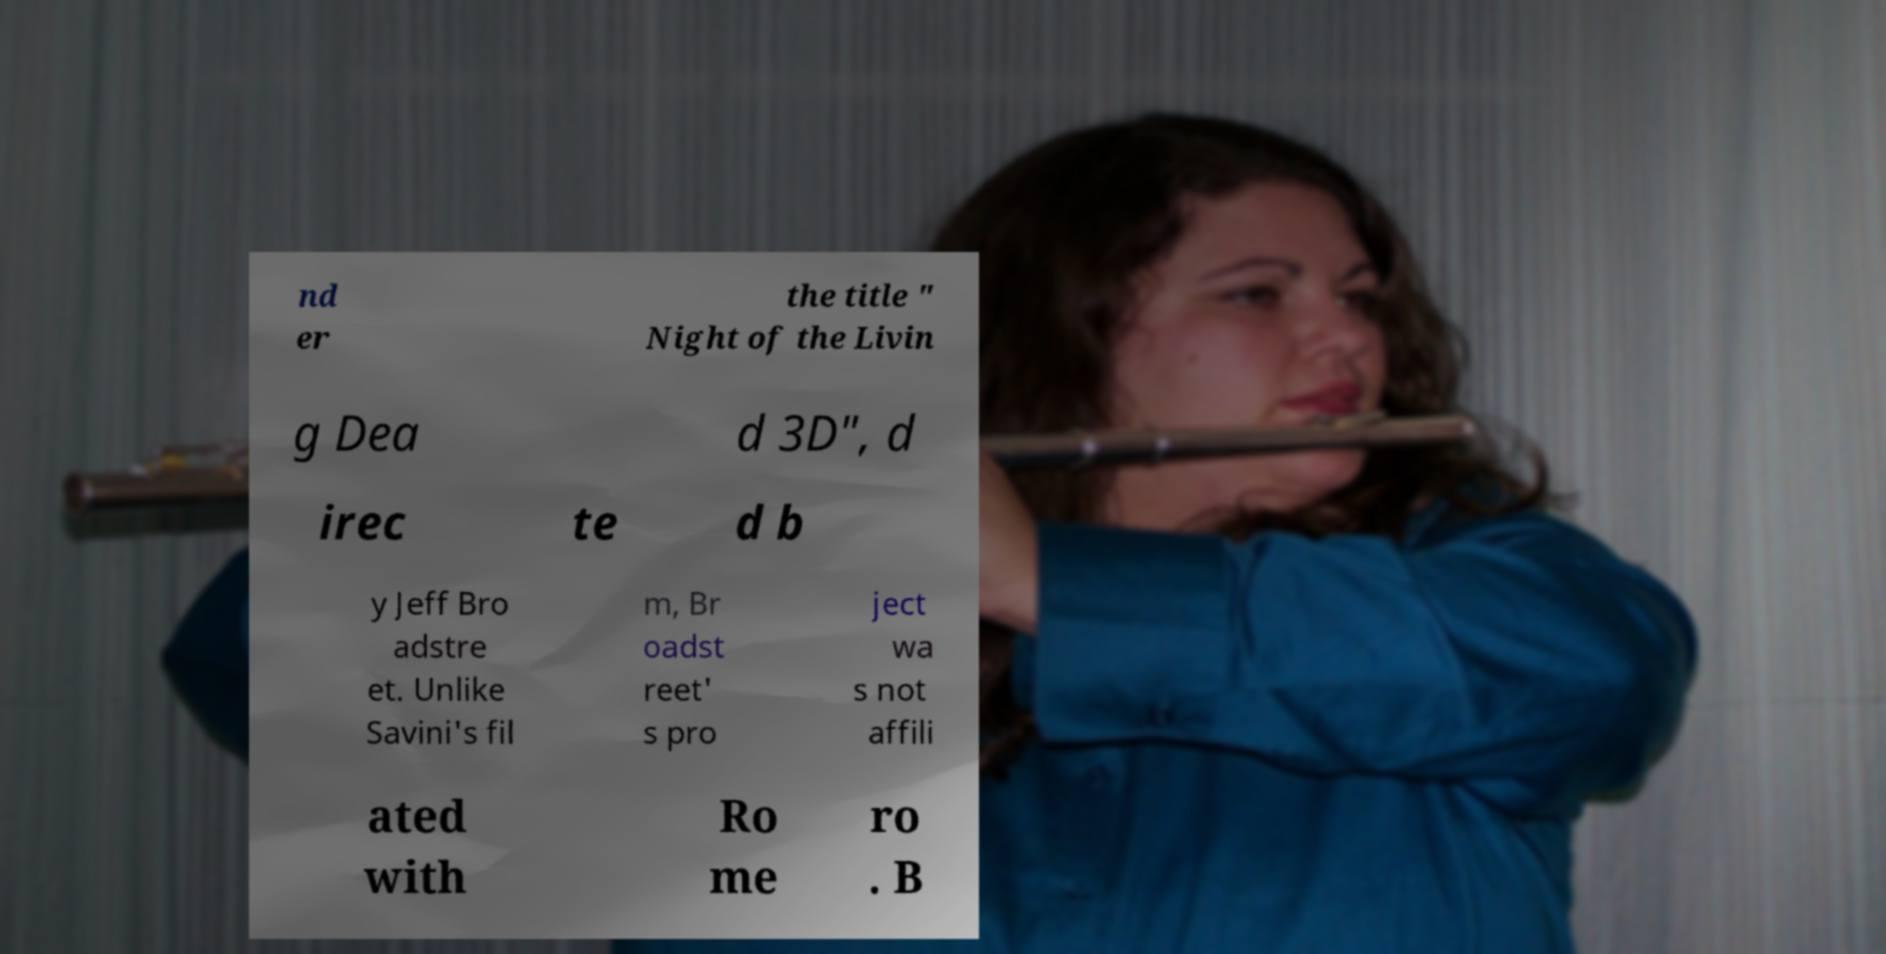Can you read and provide the text displayed in the image?This photo seems to have some interesting text. Can you extract and type it out for me? nd er the title " Night of the Livin g Dea d 3D", d irec te d b y Jeff Bro adstre et. Unlike Savini's fil m, Br oadst reet' s pro ject wa s not affili ated with Ro me ro . B 